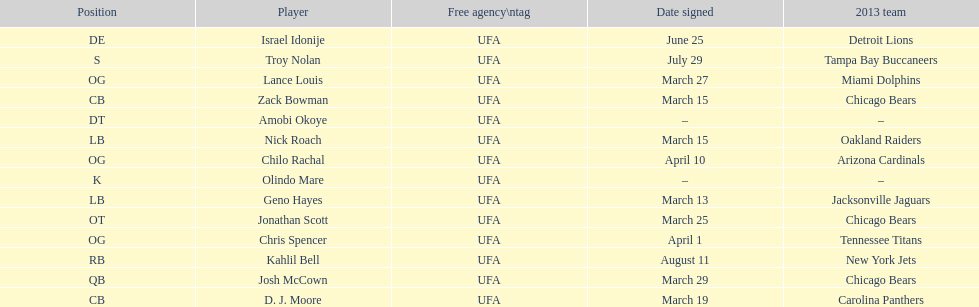What is the total of 2013 teams on the chart? 10. 